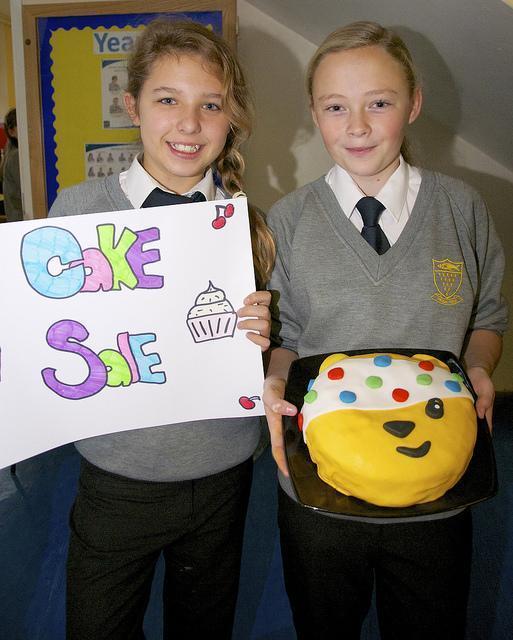How many people are there?
Give a very brief answer. 2. How many towels are hanging from the oven door?
Give a very brief answer. 0. 